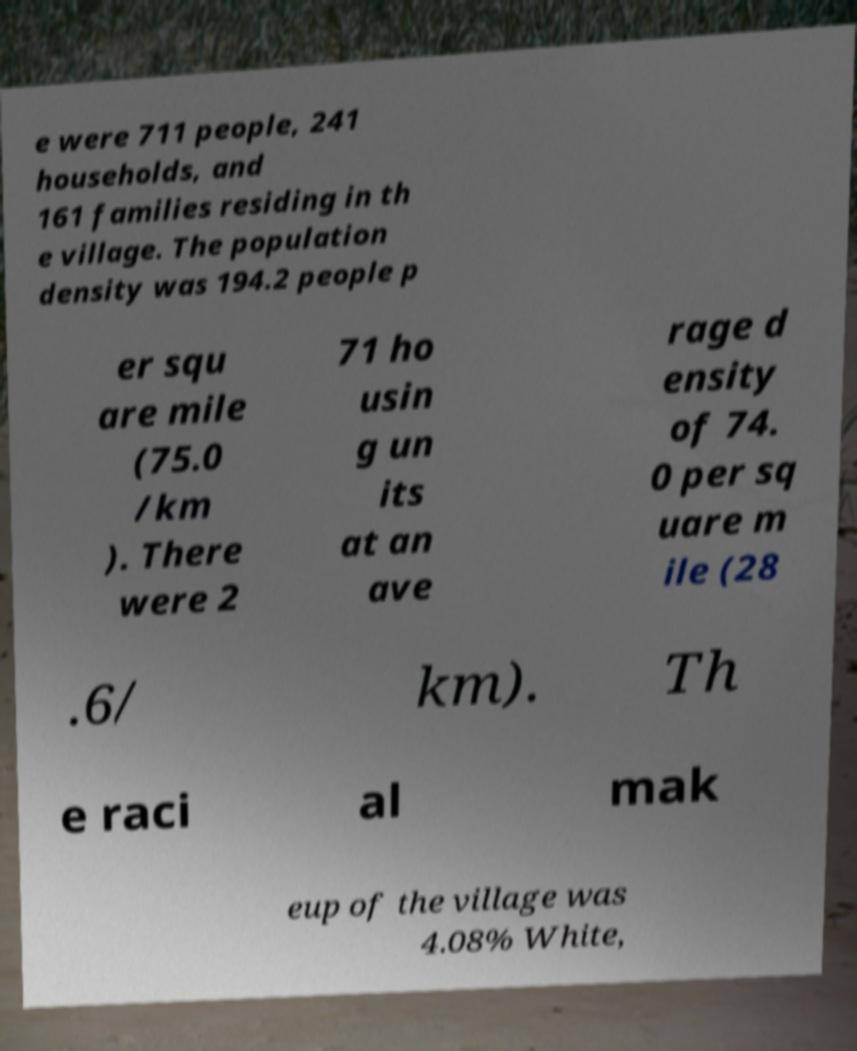What messages or text are displayed in this image? I need them in a readable, typed format. e were 711 people, 241 households, and 161 families residing in th e village. The population density was 194.2 people p er squ are mile (75.0 /km ). There were 2 71 ho usin g un its at an ave rage d ensity of 74. 0 per sq uare m ile (28 .6/ km). Th e raci al mak eup of the village was 4.08% White, 